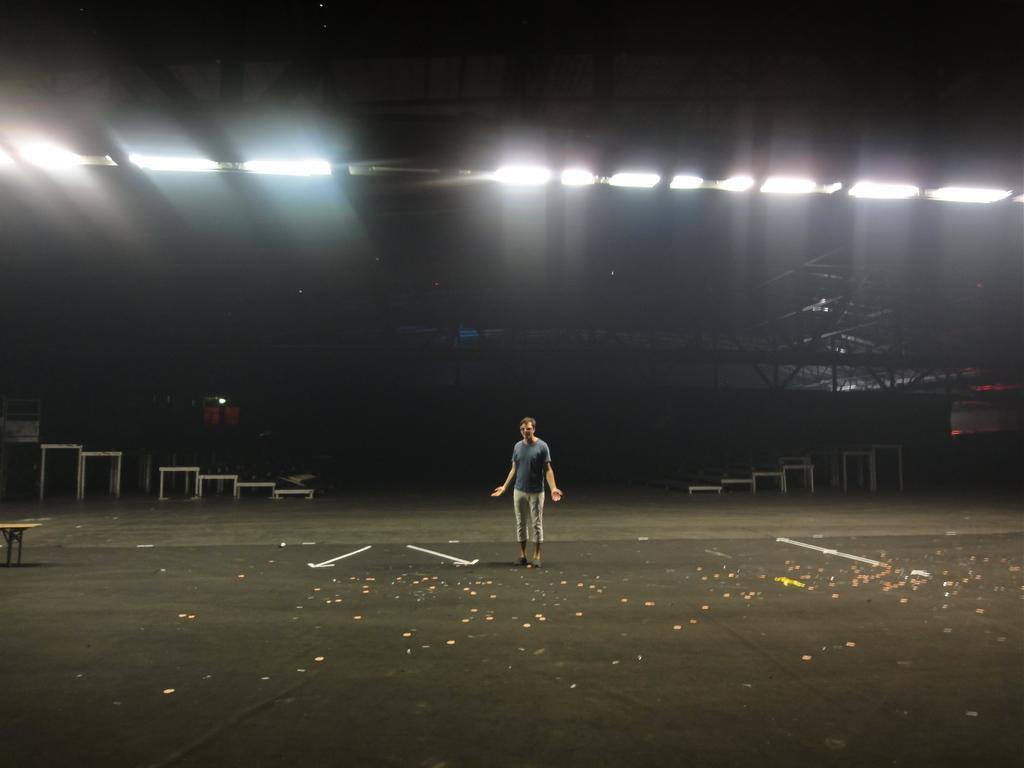In one or two sentences, can you explain what this image depicts? In the picture I can see a person standing on the black color surface. The background of the image is dark, where I can see tables and ceiling lights. 